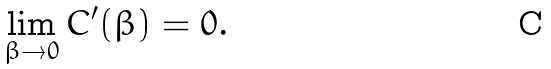Convert formula to latex. <formula><loc_0><loc_0><loc_500><loc_500>\lim _ { \beta \to 0 } C ^ { \prime } ( \beta ) = 0 .</formula> 